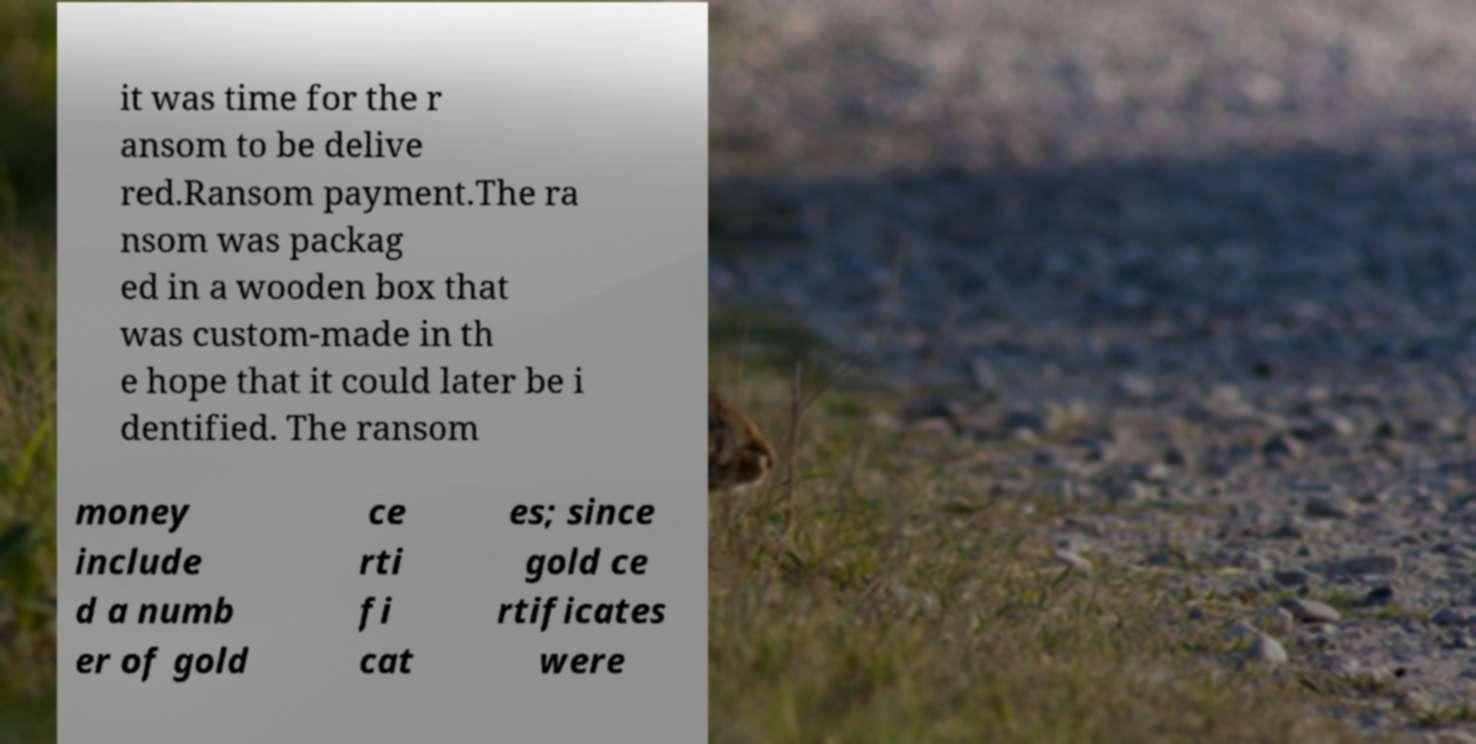I need the written content from this picture converted into text. Can you do that? it was time for the r ansom to be delive red.Ransom payment.The ra nsom was packag ed in a wooden box that was custom-made in th e hope that it could later be i dentified. The ransom money include d a numb er of gold ce rti fi cat es; since gold ce rtificates were 